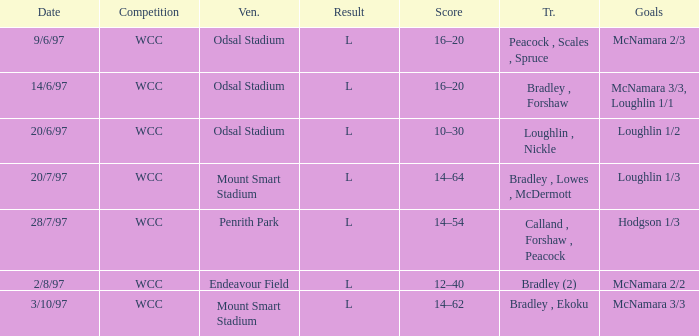What was the score on 20/6/97? 10–30. 